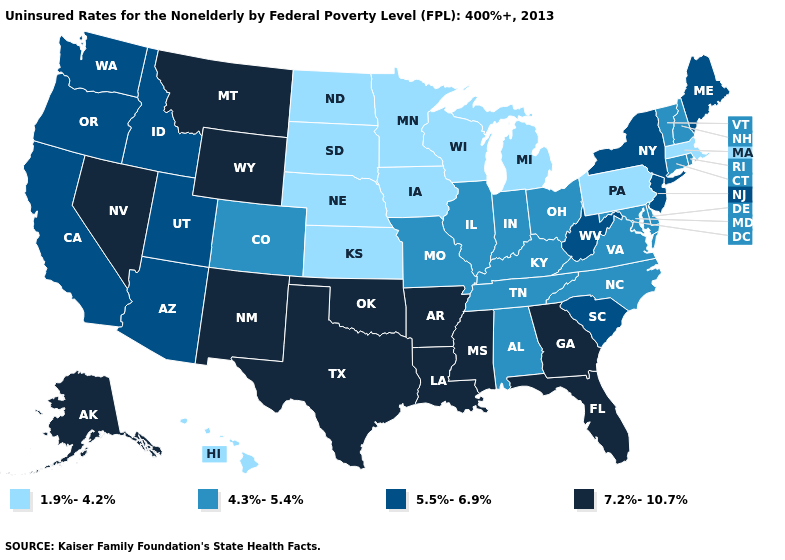Among the states that border California , does Nevada have the highest value?
Keep it brief. Yes. What is the value of Wyoming?
Be succinct. 7.2%-10.7%. Name the states that have a value in the range 7.2%-10.7%?
Answer briefly. Alaska, Arkansas, Florida, Georgia, Louisiana, Mississippi, Montana, Nevada, New Mexico, Oklahoma, Texas, Wyoming. What is the lowest value in states that border California?
Write a very short answer. 5.5%-6.9%. What is the value of Ohio?
Answer briefly. 4.3%-5.4%. What is the lowest value in the Northeast?
Concise answer only. 1.9%-4.2%. Which states have the lowest value in the Northeast?
Answer briefly. Massachusetts, Pennsylvania. Name the states that have a value in the range 4.3%-5.4%?
Short answer required. Alabama, Colorado, Connecticut, Delaware, Illinois, Indiana, Kentucky, Maryland, Missouri, New Hampshire, North Carolina, Ohio, Rhode Island, Tennessee, Vermont, Virginia. What is the lowest value in the Northeast?
Keep it brief. 1.9%-4.2%. What is the highest value in the Northeast ?
Keep it brief. 5.5%-6.9%. Name the states that have a value in the range 7.2%-10.7%?
Write a very short answer. Alaska, Arkansas, Florida, Georgia, Louisiana, Mississippi, Montana, Nevada, New Mexico, Oklahoma, Texas, Wyoming. Name the states that have a value in the range 1.9%-4.2%?
Short answer required. Hawaii, Iowa, Kansas, Massachusetts, Michigan, Minnesota, Nebraska, North Dakota, Pennsylvania, South Dakota, Wisconsin. Name the states that have a value in the range 4.3%-5.4%?
Concise answer only. Alabama, Colorado, Connecticut, Delaware, Illinois, Indiana, Kentucky, Maryland, Missouri, New Hampshire, North Carolina, Ohio, Rhode Island, Tennessee, Vermont, Virginia. What is the value of New Mexico?
Concise answer only. 7.2%-10.7%. What is the value of New Jersey?
Write a very short answer. 5.5%-6.9%. 